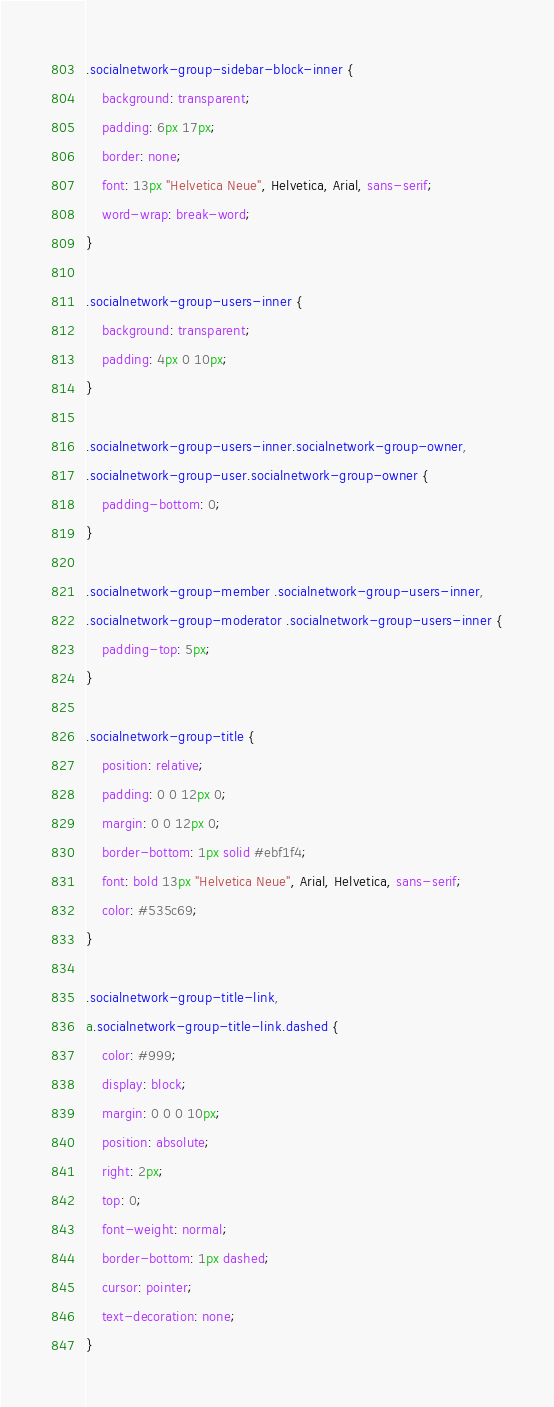<code> <loc_0><loc_0><loc_500><loc_500><_CSS_>.socialnetwork-group-sidebar-block-inner {
	background: transparent;
	padding: 6px 17px;
	border: none;
	font: 13px "Helvetica Neue", Helvetica, Arial, sans-serif;
	word-wrap: break-word;
}

.socialnetwork-group-users-inner {
	background: transparent;
	padding: 4px 0 10px;
}

.socialnetwork-group-users-inner.socialnetwork-group-owner,
.socialnetwork-group-user.socialnetwork-group-owner {
	padding-bottom: 0;
}

.socialnetwork-group-member .socialnetwork-group-users-inner,
.socialnetwork-group-moderator .socialnetwork-group-users-inner {
	padding-top: 5px;
}

.socialnetwork-group-title {
	position: relative;
	padding: 0 0 12px 0;
	margin: 0 0 12px 0;
	border-bottom: 1px solid #ebf1f4;
	font: bold 13px "Helvetica Neue", Arial, Helvetica, sans-serif;
	color: #535c69;
}

.socialnetwork-group-title-link,
a.socialnetwork-group-title-link.dashed {
	color: #999;
	display: block;
	margin: 0 0 0 10px;
	position: absolute;
	right: 2px;
	top: 0;
	font-weight: normal;
	border-bottom: 1px dashed;
	cursor: pointer;
	text-decoration: none;
}
</code> 